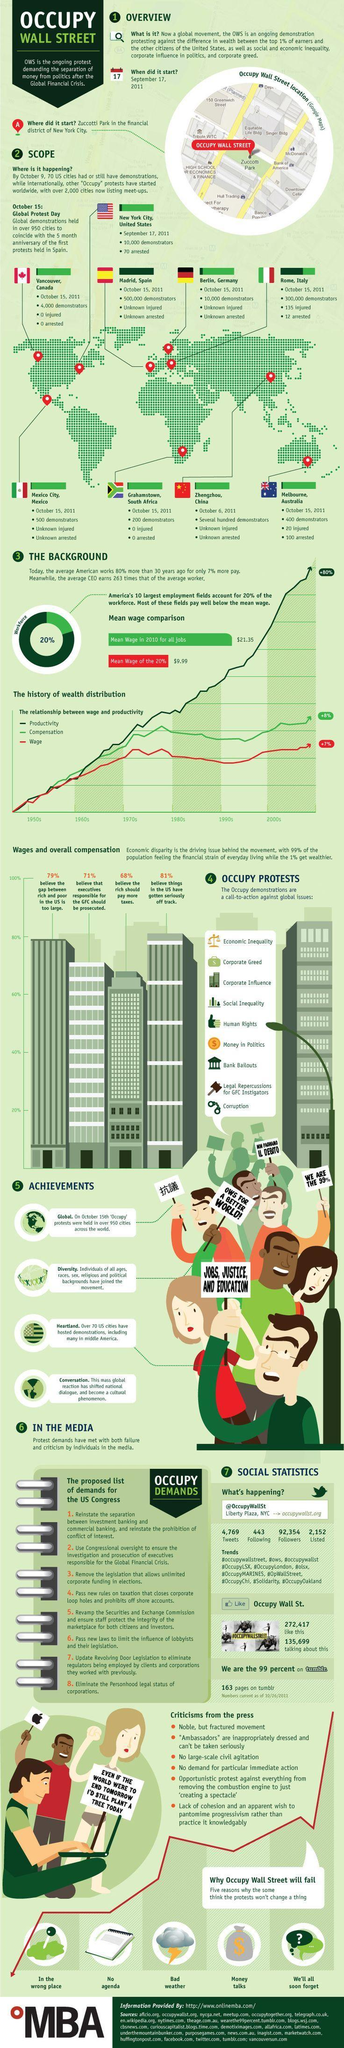Which city had  an unknown number of protestors?
Answer the question with a short phrase. Zhenghzhou, China What is the name of the building located towards the right of Zuccoti park? Bank of America How many reasons may lead to the failure of Occupy Wall Street? 5 Which city had the highest number of protestors on October 15, 2011 ? Madrid, Spain 